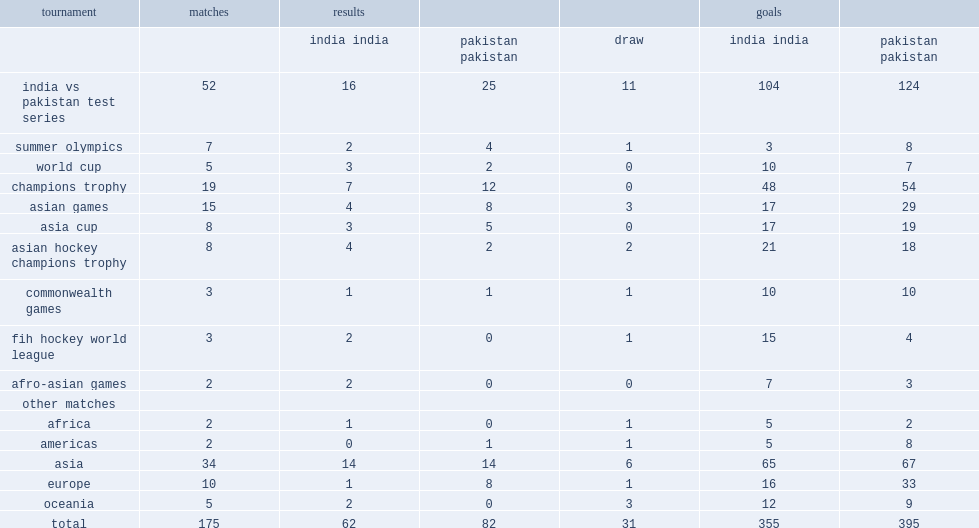How many goals did pakistan socre in india vs pakistan test series? 124.0. 